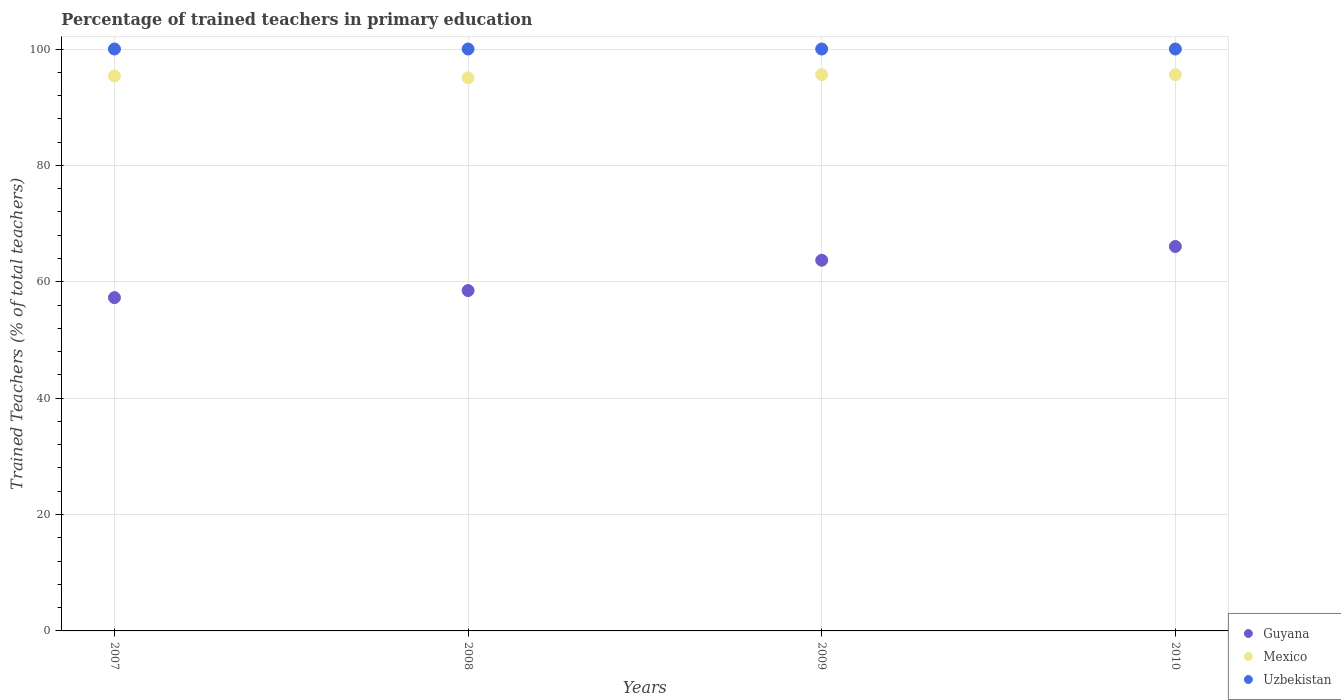Is the number of dotlines equal to the number of legend labels?
Give a very brief answer. Yes. What is the percentage of trained teachers in Uzbekistan in 2009?
Keep it short and to the point. 100. Across all years, what is the minimum percentage of trained teachers in Mexico?
Offer a terse response. 95.05. In which year was the percentage of trained teachers in Mexico maximum?
Offer a very short reply. 2009. In which year was the percentage of trained teachers in Uzbekistan minimum?
Keep it short and to the point. 2007. What is the total percentage of trained teachers in Uzbekistan in the graph?
Your answer should be very brief. 400. What is the difference between the percentage of trained teachers in Uzbekistan in 2009 and that in 2010?
Make the answer very short. 0. What is the difference between the percentage of trained teachers in Mexico in 2010 and the percentage of trained teachers in Guyana in 2007?
Your answer should be compact. 38.31. In the year 2010, what is the difference between the percentage of trained teachers in Guyana and percentage of trained teachers in Uzbekistan?
Make the answer very short. -33.94. What is the ratio of the percentage of trained teachers in Uzbekistan in 2007 to that in 2010?
Your answer should be very brief. 1. Is the percentage of trained teachers in Mexico in 2007 less than that in 2010?
Offer a very short reply. Yes. Is the difference between the percentage of trained teachers in Guyana in 2008 and 2010 greater than the difference between the percentage of trained teachers in Uzbekistan in 2008 and 2010?
Keep it short and to the point. No. What is the difference between the highest and the second highest percentage of trained teachers in Uzbekistan?
Your response must be concise. 0. What is the difference between the highest and the lowest percentage of trained teachers in Uzbekistan?
Provide a succinct answer. 0. Is the sum of the percentage of trained teachers in Guyana in 2007 and 2008 greater than the maximum percentage of trained teachers in Mexico across all years?
Your answer should be compact. Yes. Is the percentage of trained teachers in Guyana strictly greater than the percentage of trained teachers in Mexico over the years?
Your answer should be compact. No. Are the values on the major ticks of Y-axis written in scientific E-notation?
Keep it short and to the point. No. Does the graph contain any zero values?
Provide a succinct answer. No. Does the graph contain grids?
Offer a very short reply. Yes. Where does the legend appear in the graph?
Your answer should be very brief. Bottom right. How many legend labels are there?
Your answer should be compact. 3. What is the title of the graph?
Provide a short and direct response. Percentage of trained teachers in primary education. Does "Netherlands" appear as one of the legend labels in the graph?
Provide a succinct answer. No. What is the label or title of the X-axis?
Provide a succinct answer. Years. What is the label or title of the Y-axis?
Ensure brevity in your answer.  Trained Teachers (% of total teachers). What is the Trained Teachers (% of total teachers) in Guyana in 2007?
Provide a short and direct response. 57.27. What is the Trained Teachers (% of total teachers) in Mexico in 2007?
Your answer should be compact. 95.37. What is the Trained Teachers (% of total teachers) in Uzbekistan in 2007?
Make the answer very short. 100. What is the Trained Teachers (% of total teachers) in Guyana in 2008?
Offer a very short reply. 58.49. What is the Trained Teachers (% of total teachers) in Mexico in 2008?
Offer a very short reply. 95.05. What is the Trained Teachers (% of total teachers) of Uzbekistan in 2008?
Your response must be concise. 100. What is the Trained Teachers (% of total teachers) in Guyana in 2009?
Give a very brief answer. 63.7. What is the Trained Teachers (% of total teachers) in Mexico in 2009?
Your answer should be compact. 95.59. What is the Trained Teachers (% of total teachers) of Guyana in 2010?
Ensure brevity in your answer.  66.06. What is the Trained Teachers (% of total teachers) of Mexico in 2010?
Make the answer very short. 95.59. What is the Trained Teachers (% of total teachers) of Uzbekistan in 2010?
Make the answer very short. 100. Across all years, what is the maximum Trained Teachers (% of total teachers) of Guyana?
Your answer should be compact. 66.06. Across all years, what is the maximum Trained Teachers (% of total teachers) in Mexico?
Make the answer very short. 95.59. Across all years, what is the maximum Trained Teachers (% of total teachers) in Uzbekistan?
Make the answer very short. 100. Across all years, what is the minimum Trained Teachers (% of total teachers) in Guyana?
Provide a succinct answer. 57.27. Across all years, what is the minimum Trained Teachers (% of total teachers) in Mexico?
Offer a very short reply. 95.05. Across all years, what is the minimum Trained Teachers (% of total teachers) in Uzbekistan?
Make the answer very short. 100. What is the total Trained Teachers (% of total teachers) in Guyana in the graph?
Ensure brevity in your answer.  245.53. What is the total Trained Teachers (% of total teachers) of Mexico in the graph?
Keep it short and to the point. 381.59. What is the total Trained Teachers (% of total teachers) of Uzbekistan in the graph?
Make the answer very short. 400. What is the difference between the Trained Teachers (% of total teachers) of Guyana in 2007 and that in 2008?
Offer a terse response. -1.22. What is the difference between the Trained Teachers (% of total teachers) in Mexico in 2007 and that in 2008?
Offer a very short reply. 0.32. What is the difference between the Trained Teachers (% of total teachers) of Guyana in 2007 and that in 2009?
Provide a short and direct response. -6.43. What is the difference between the Trained Teachers (% of total teachers) in Mexico in 2007 and that in 2009?
Your answer should be compact. -0.22. What is the difference between the Trained Teachers (% of total teachers) of Uzbekistan in 2007 and that in 2009?
Your answer should be compact. 0. What is the difference between the Trained Teachers (% of total teachers) in Guyana in 2007 and that in 2010?
Provide a short and direct response. -8.79. What is the difference between the Trained Teachers (% of total teachers) of Mexico in 2007 and that in 2010?
Your response must be concise. -0.22. What is the difference between the Trained Teachers (% of total teachers) in Guyana in 2008 and that in 2009?
Keep it short and to the point. -5.21. What is the difference between the Trained Teachers (% of total teachers) in Mexico in 2008 and that in 2009?
Ensure brevity in your answer.  -0.54. What is the difference between the Trained Teachers (% of total teachers) in Uzbekistan in 2008 and that in 2009?
Ensure brevity in your answer.  0. What is the difference between the Trained Teachers (% of total teachers) of Guyana in 2008 and that in 2010?
Your answer should be very brief. -7.57. What is the difference between the Trained Teachers (% of total teachers) of Mexico in 2008 and that in 2010?
Provide a short and direct response. -0.54. What is the difference between the Trained Teachers (% of total teachers) in Uzbekistan in 2008 and that in 2010?
Keep it short and to the point. 0. What is the difference between the Trained Teachers (% of total teachers) in Guyana in 2009 and that in 2010?
Provide a short and direct response. -2.36. What is the difference between the Trained Teachers (% of total teachers) of Mexico in 2009 and that in 2010?
Give a very brief answer. 0. What is the difference between the Trained Teachers (% of total teachers) of Uzbekistan in 2009 and that in 2010?
Provide a succinct answer. 0. What is the difference between the Trained Teachers (% of total teachers) of Guyana in 2007 and the Trained Teachers (% of total teachers) of Mexico in 2008?
Your answer should be compact. -37.77. What is the difference between the Trained Teachers (% of total teachers) of Guyana in 2007 and the Trained Teachers (% of total teachers) of Uzbekistan in 2008?
Make the answer very short. -42.73. What is the difference between the Trained Teachers (% of total teachers) in Mexico in 2007 and the Trained Teachers (% of total teachers) in Uzbekistan in 2008?
Give a very brief answer. -4.63. What is the difference between the Trained Teachers (% of total teachers) of Guyana in 2007 and the Trained Teachers (% of total teachers) of Mexico in 2009?
Make the answer very short. -38.32. What is the difference between the Trained Teachers (% of total teachers) of Guyana in 2007 and the Trained Teachers (% of total teachers) of Uzbekistan in 2009?
Offer a terse response. -42.73. What is the difference between the Trained Teachers (% of total teachers) in Mexico in 2007 and the Trained Teachers (% of total teachers) in Uzbekistan in 2009?
Provide a succinct answer. -4.63. What is the difference between the Trained Teachers (% of total teachers) in Guyana in 2007 and the Trained Teachers (% of total teachers) in Mexico in 2010?
Offer a terse response. -38.31. What is the difference between the Trained Teachers (% of total teachers) in Guyana in 2007 and the Trained Teachers (% of total teachers) in Uzbekistan in 2010?
Your response must be concise. -42.73. What is the difference between the Trained Teachers (% of total teachers) in Mexico in 2007 and the Trained Teachers (% of total teachers) in Uzbekistan in 2010?
Keep it short and to the point. -4.63. What is the difference between the Trained Teachers (% of total teachers) in Guyana in 2008 and the Trained Teachers (% of total teachers) in Mexico in 2009?
Offer a terse response. -37.1. What is the difference between the Trained Teachers (% of total teachers) in Guyana in 2008 and the Trained Teachers (% of total teachers) in Uzbekistan in 2009?
Make the answer very short. -41.51. What is the difference between the Trained Teachers (% of total teachers) of Mexico in 2008 and the Trained Teachers (% of total teachers) of Uzbekistan in 2009?
Your answer should be very brief. -4.95. What is the difference between the Trained Teachers (% of total teachers) in Guyana in 2008 and the Trained Teachers (% of total teachers) in Mexico in 2010?
Ensure brevity in your answer.  -37.09. What is the difference between the Trained Teachers (% of total teachers) of Guyana in 2008 and the Trained Teachers (% of total teachers) of Uzbekistan in 2010?
Keep it short and to the point. -41.51. What is the difference between the Trained Teachers (% of total teachers) in Mexico in 2008 and the Trained Teachers (% of total teachers) in Uzbekistan in 2010?
Ensure brevity in your answer.  -4.95. What is the difference between the Trained Teachers (% of total teachers) of Guyana in 2009 and the Trained Teachers (% of total teachers) of Mexico in 2010?
Your answer should be compact. -31.89. What is the difference between the Trained Teachers (% of total teachers) of Guyana in 2009 and the Trained Teachers (% of total teachers) of Uzbekistan in 2010?
Provide a short and direct response. -36.3. What is the difference between the Trained Teachers (% of total teachers) in Mexico in 2009 and the Trained Teachers (% of total teachers) in Uzbekistan in 2010?
Make the answer very short. -4.41. What is the average Trained Teachers (% of total teachers) of Guyana per year?
Provide a short and direct response. 61.38. What is the average Trained Teachers (% of total teachers) of Mexico per year?
Provide a succinct answer. 95.4. In the year 2007, what is the difference between the Trained Teachers (% of total teachers) of Guyana and Trained Teachers (% of total teachers) of Mexico?
Give a very brief answer. -38.1. In the year 2007, what is the difference between the Trained Teachers (% of total teachers) of Guyana and Trained Teachers (% of total teachers) of Uzbekistan?
Offer a terse response. -42.73. In the year 2007, what is the difference between the Trained Teachers (% of total teachers) in Mexico and Trained Teachers (% of total teachers) in Uzbekistan?
Keep it short and to the point. -4.63. In the year 2008, what is the difference between the Trained Teachers (% of total teachers) of Guyana and Trained Teachers (% of total teachers) of Mexico?
Offer a very short reply. -36.55. In the year 2008, what is the difference between the Trained Teachers (% of total teachers) in Guyana and Trained Teachers (% of total teachers) in Uzbekistan?
Your answer should be compact. -41.51. In the year 2008, what is the difference between the Trained Teachers (% of total teachers) in Mexico and Trained Teachers (% of total teachers) in Uzbekistan?
Your response must be concise. -4.95. In the year 2009, what is the difference between the Trained Teachers (% of total teachers) in Guyana and Trained Teachers (% of total teachers) in Mexico?
Offer a very short reply. -31.89. In the year 2009, what is the difference between the Trained Teachers (% of total teachers) in Guyana and Trained Teachers (% of total teachers) in Uzbekistan?
Keep it short and to the point. -36.3. In the year 2009, what is the difference between the Trained Teachers (% of total teachers) of Mexico and Trained Teachers (% of total teachers) of Uzbekistan?
Your answer should be compact. -4.41. In the year 2010, what is the difference between the Trained Teachers (% of total teachers) in Guyana and Trained Teachers (% of total teachers) in Mexico?
Your answer should be very brief. -29.52. In the year 2010, what is the difference between the Trained Teachers (% of total teachers) of Guyana and Trained Teachers (% of total teachers) of Uzbekistan?
Make the answer very short. -33.94. In the year 2010, what is the difference between the Trained Teachers (% of total teachers) of Mexico and Trained Teachers (% of total teachers) of Uzbekistan?
Provide a succinct answer. -4.41. What is the ratio of the Trained Teachers (% of total teachers) of Guyana in 2007 to that in 2008?
Provide a short and direct response. 0.98. What is the ratio of the Trained Teachers (% of total teachers) in Uzbekistan in 2007 to that in 2008?
Keep it short and to the point. 1. What is the ratio of the Trained Teachers (% of total teachers) in Guyana in 2007 to that in 2009?
Offer a very short reply. 0.9. What is the ratio of the Trained Teachers (% of total teachers) in Guyana in 2007 to that in 2010?
Give a very brief answer. 0.87. What is the ratio of the Trained Teachers (% of total teachers) of Guyana in 2008 to that in 2009?
Provide a short and direct response. 0.92. What is the ratio of the Trained Teachers (% of total teachers) in Guyana in 2008 to that in 2010?
Your answer should be very brief. 0.89. What is the ratio of the Trained Teachers (% of total teachers) of Uzbekistan in 2008 to that in 2010?
Offer a terse response. 1. What is the ratio of the Trained Teachers (% of total teachers) of Guyana in 2009 to that in 2010?
Offer a very short reply. 0.96. What is the ratio of the Trained Teachers (% of total teachers) of Mexico in 2009 to that in 2010?
Keep it short and to the point. 1. What is the difference between the highest and the second highest Trained Teachers (% of total teachers) in Guyana?
Your answer should be compact. 2.36. What is the difference between the highest and the second highest Trained Teachers (% of total teachers) in Mexico?
Make the answer very short. 0. What is the difference between the highest and the second highest Trained Teachers (% of total teachers) in Uzbekistan?
Provide a succinct answer. 0. What is the difference between the highest and the lowest Trained Teachers (% of total teachers) of Guyana?
Ensure brevity in your answer.  8.79. What is the difference between the highest and the lowest Trained Teachers (% of total teachers) of Mexico?
Ensure brevity in your answer.  0.54. What is the difference between the highest and the lowest Trained Teachers (% of total teachers) of Uzbekistan?
Provide a succinct answer. 0. 